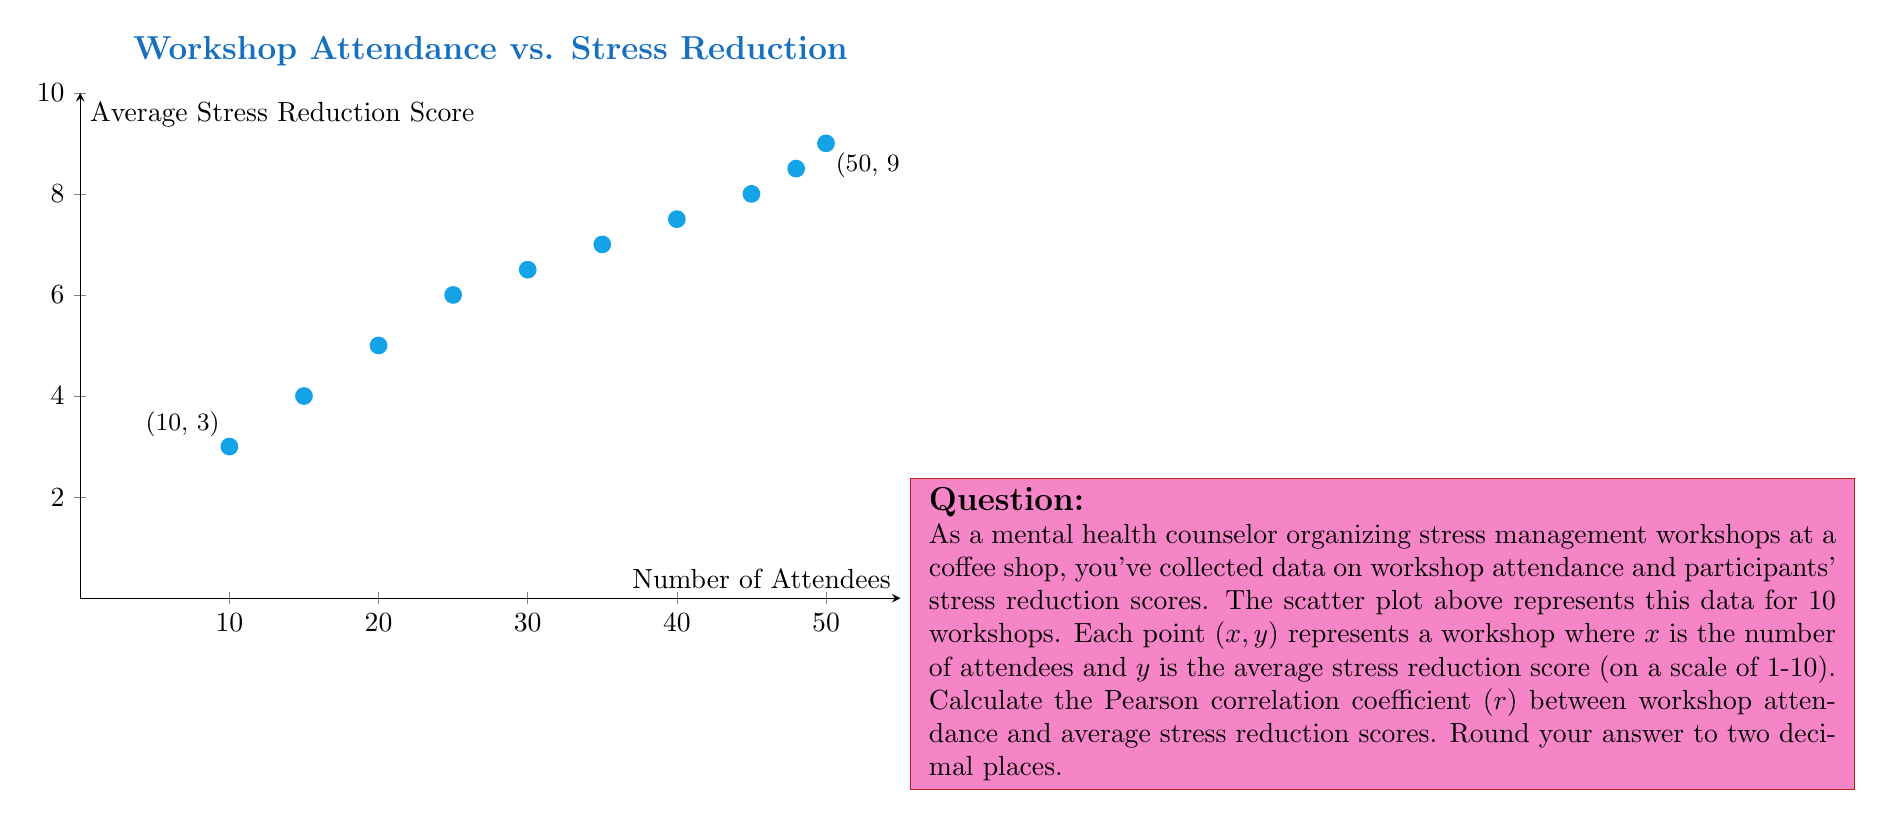Teach me how to tackle this problem. To calculate the Pearson correlation coefficient (r), we'll follow these steps:

1) First, we need to calculate the means of x (attendance) and y (stress reduction scores):

   $\bar{x} = \frac{10 + 15 + 20 + 25 + 30 + 35 + 40 + 45 + 48 + 50}{10} = 31.8$
   $\bar{y} = \frac{3 + 4 + 5 + 6 + 6.5 + 7 + 7.5 + 8 + 8.5 + 9}{10} = 6.45$

2) Now, we'll calculate the numerator of the correlation coefficient formula:
   
   $\sum_{i=1}^{n} (x_i - \bar{x})(y_i - \bar{y})$

3) And the denominator parts:
   
   $\sqrt{\sum_{i=1}^{n} (x_i - \bar{x})^2}$ and $\sqrt{\sum_{i=1}^{n} (y_i - \bar{y})^2}$

4) Putting it all together in the formula:

   $r = \frac{\sum_{i=1}^{n} (x_i - \bar{x})(y_i - \bar{y})}{\sqrt{\sum_{i=1}^{n} (x_i - \bar{x})^2} \sqrt{\sum_{i=1}^{n} (y_i - \bar{y})^2}}$

5) After calculations:

   $r = \frac{1226.65}{\sqrt{3124.2} \sqrt{48.0275}} = \frac{1226.65}{387.5766} = 0.9769$

6) Rounding to two decimal places:

   $r \approx 0.98$
Answer: 0.98 